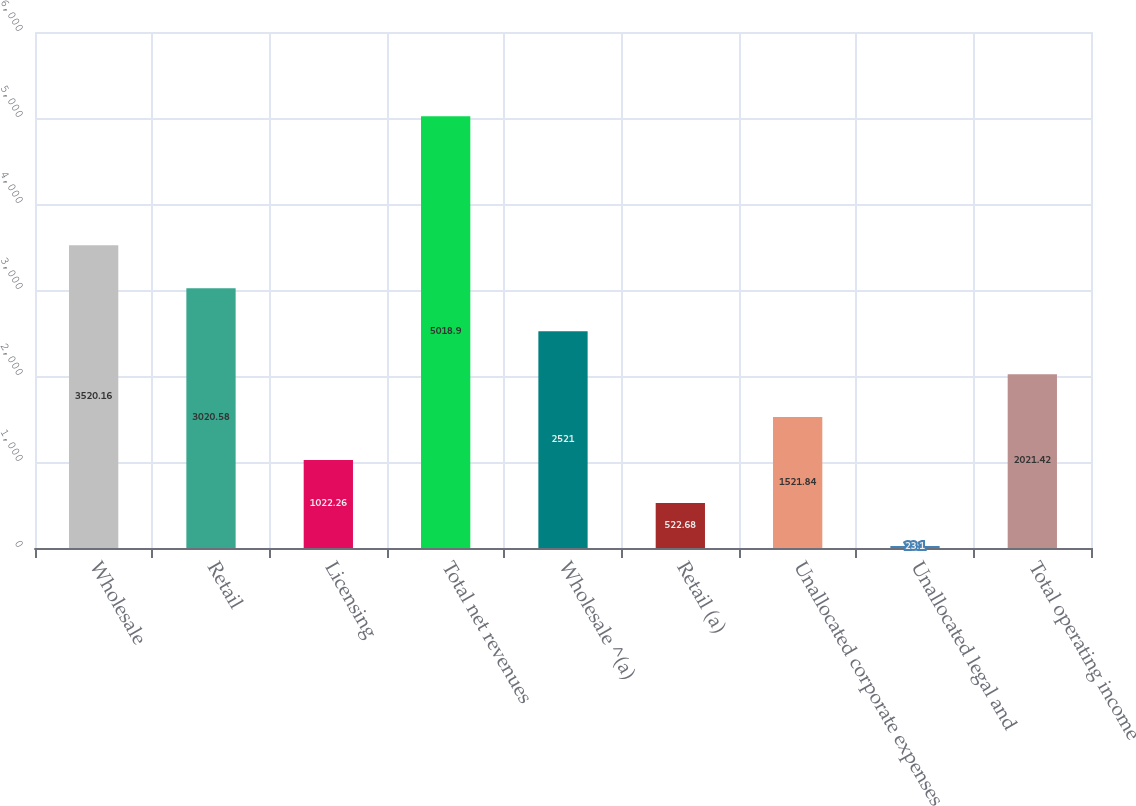Convert chart. <chart><loc_0><loc_0><loc_500><loc_500><bar_chart><fcel>Wholesale<fcel>Retail<fcel>Licensing<fcel>Total net revenues<fcel>Wholesale ^(a)<fcel>Retail (a)<fcel>Unallocated corporate expenses<fcel>Unallocated legal and<fcel>Total operating income<nl><fcel>3520.16<fcel>3020.58<fcel>1022.26<fcel>5018.9<fcel>2521<fcel>522.68<fcel>1521.84<fcel>23.1<fcel>2021.42<nl></chart> 